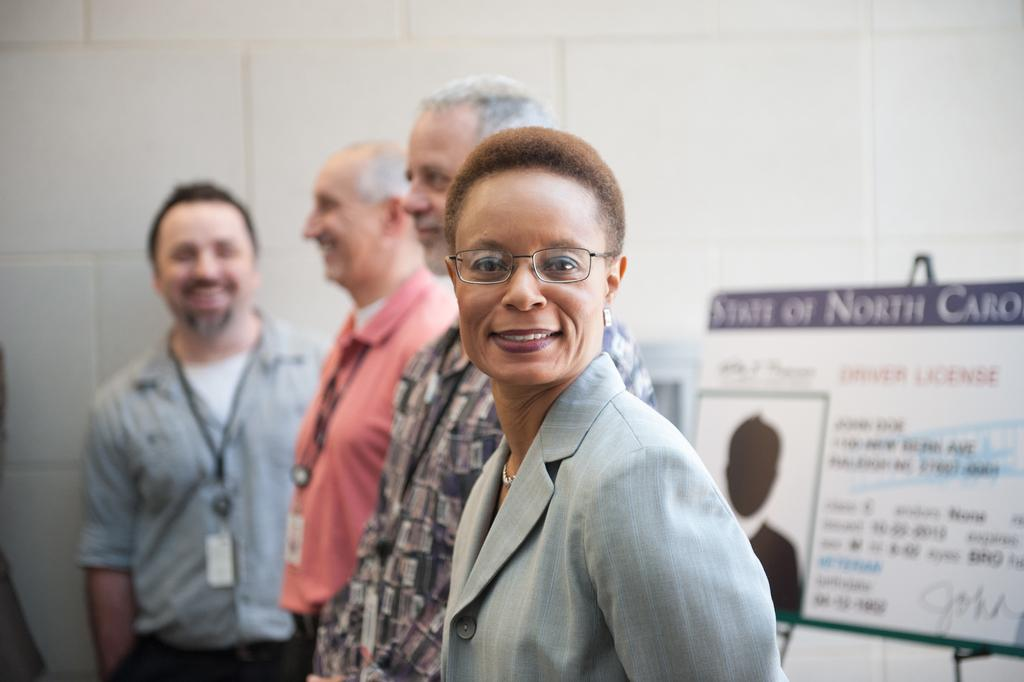How many people are in the image? There are persons standing in the image. What can be seen in the background on the right side of the image? There is a board on a stand and a wall in the background on the right side of the image. What type of juice is being served from the screw in the image? There is no screw or juice present in the image. 